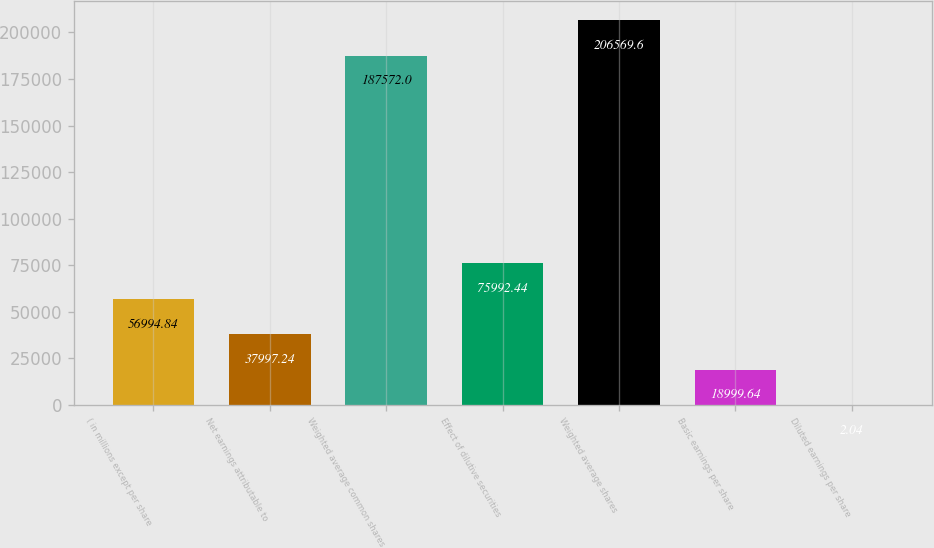<chart> <loc_0><loc_0><loc_500><loc_500><bar_chart><fcel>( in millions except per share<fcel>Net earnings attributable to<fcel>Weighted average common shares<fcel>Effect of dilutive securities<fcel>Weighted average shares<fcel>Basic earnings per share<fcel>Diluted earnings per share<nl><fcel>56994.8<fcel>37997.2<fcel>187572<fcel>75992.4<fcel>206570<fcel>18999.6<fcel>2.04<nl></chart> 